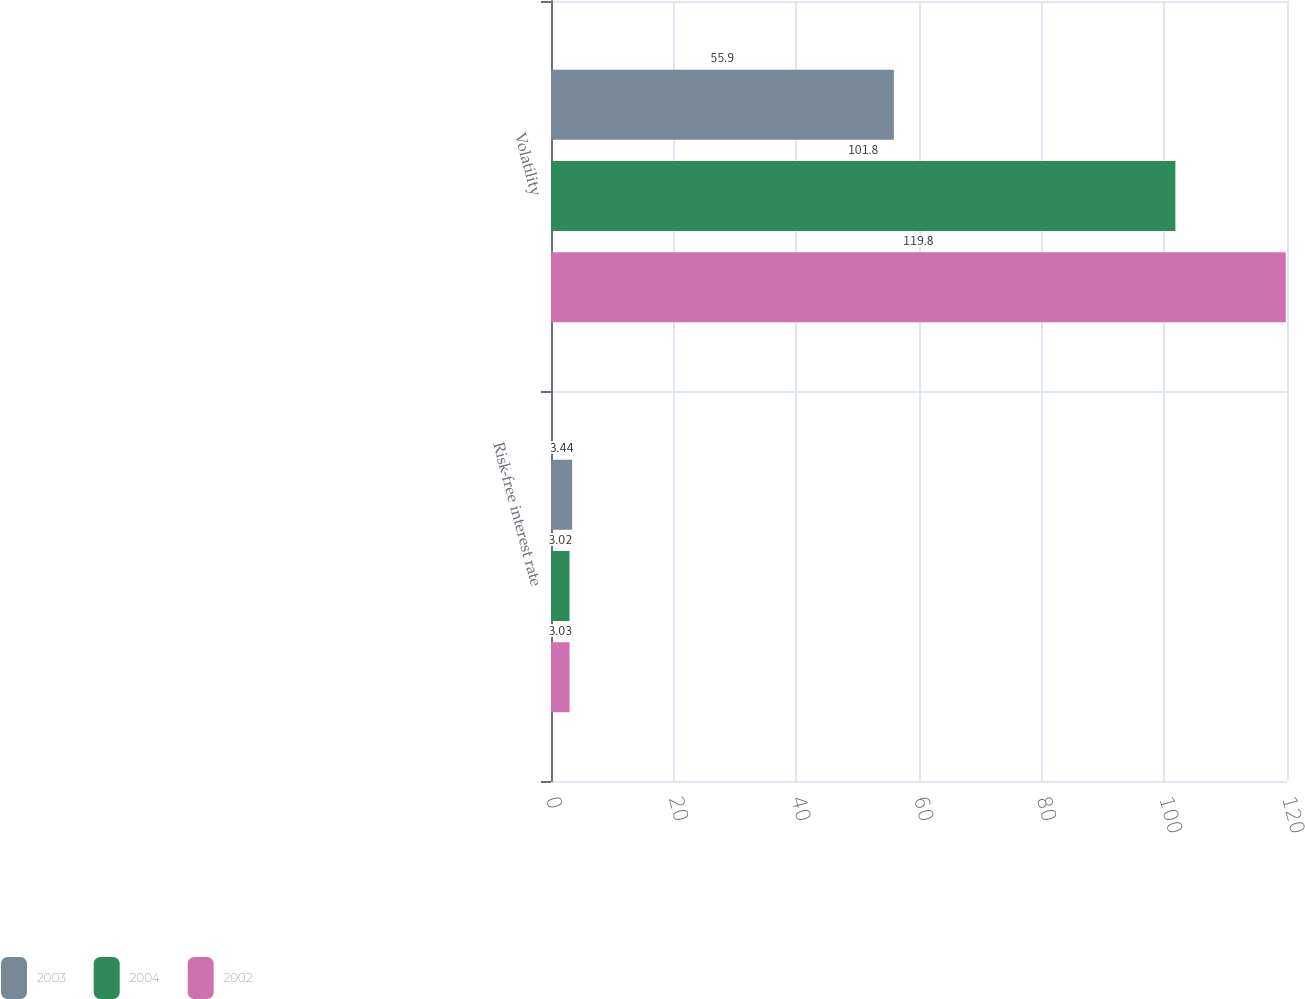Convert chart. <chart><loc_0><loc_0><loc_500><loc_500><stacked_bar_chart><ecel><fcel>Risk-free interest rate<fcel>Volatility<nl><fcel>2003<fcel>3.44<fcel>55.9<nl><fcel>2004<fcel>3.02<fcel>101.8<nl><fcel>2002<fcel>3.03<fcel>119.8<nl></chart> 